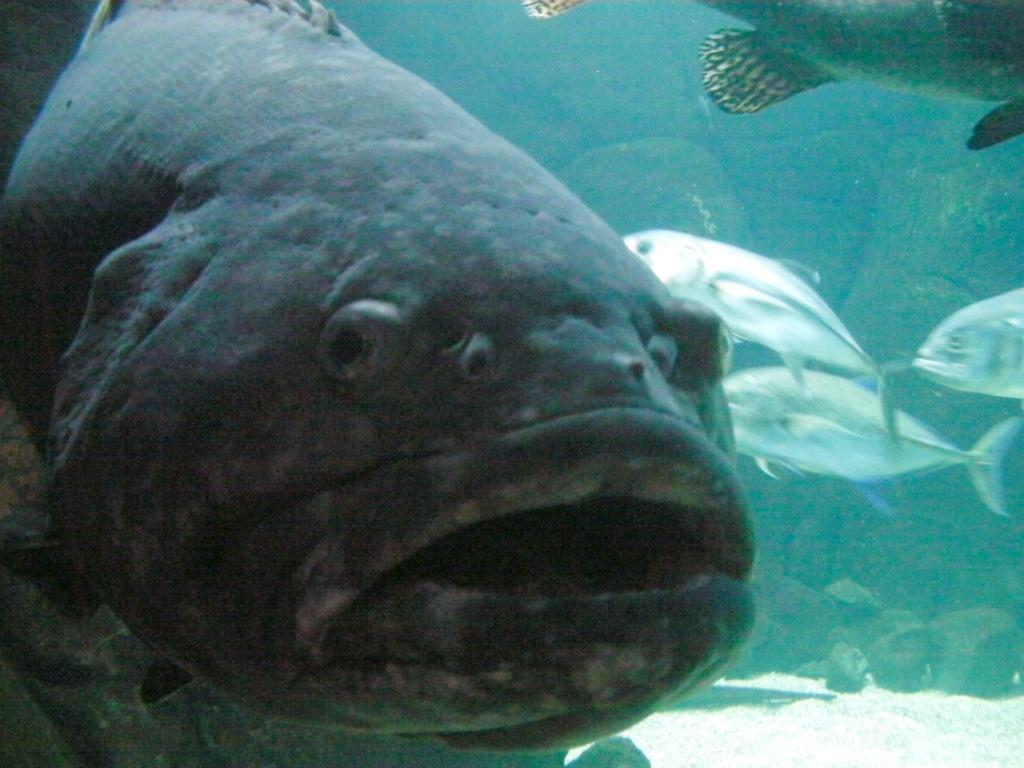What type of animals can be seen in the image? There are fishes in the image. What other objects can be seen in the image? There are stones and rocks in the image. Where are these elements located? All of these elements are in the water. What is the title of the book that is visible in the image? There is no book present in the image; it features fishes, stones, and rocks in the water. What type of stocking is being used by the fish in the image? There are no fish wearing stockings in the image; the image only shows fishes, stones, and rocks in the water. 